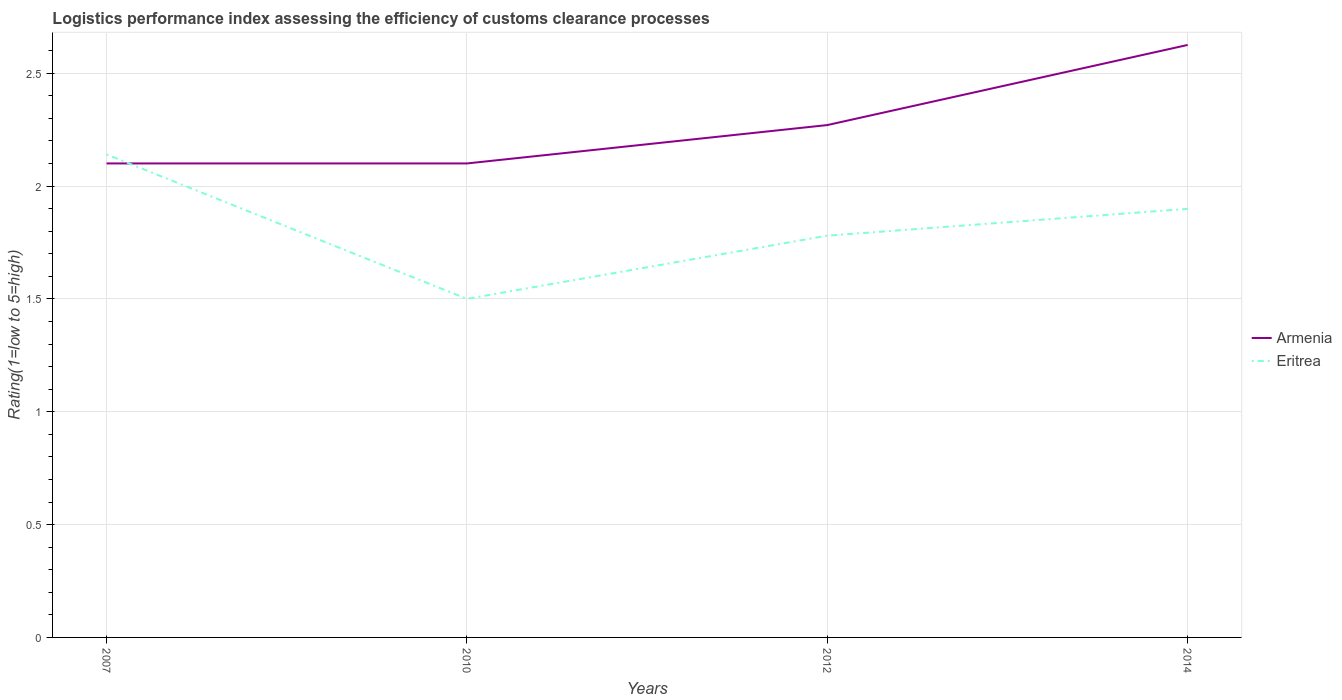Is the number of lines equal to the number of legend labels?
Ensure brevity in your answer.  Yes. Across all years, what is the maximum Logistic performance index in Eritrea?
Your answer should be compact. 1.5. In which year was the Logistic performance index in Armenia maximum?
Make the answer very short. 2007. What is the total Logistic performance index in Armenia in the graph?
Make the answer very short. -0.17. What is the difference between the highest and the second highest Logistic performance index in Eritrea?
Provide a succinct answer. 0.64. Is the Logistic performance index in Eritrea strictly greater than the Logistic performance index in Armenia over the years?
Offer a terse response. No. Are the values on the major ticks of Y-axis written in scientific E-notation?
Offer a terse response. No. Does the graph contain any zero values?
Make the answer very short. No. Does the graph contain grids?
Your answer should be very brief. Yes. How are the legend labels stacked?
Offer a very short reply. Vertical. What is the title of the graph?
Ensure brevity in your answer.  Logistics performance index assessing the efficiency of customs clearance processes. What is the label or title of the X-axis?
Your response must be concise. Years. What is the label or title of the Y-axis?
Provide a short and direct response. Rating(1=low to 5=high). What is the Rating(1=low to 5=high) in Eritrea in 2007?
Offer a terse response. 2.14. What is the Rating(1=low to 5=high) in Eritrea in 2010?
Offer a very short reply. 1.5. What is the Rating(1=low to 5=high) in Armenia in 2012?
Your response must be concise. 2.27. What is the Rating(1=low to 5=high) in Eritrea in 2012?
Make the answer very short. 1.78. What is the Rating(1=low to 5=high) in Armenia in 2014?
Keep it short and to the point. 2.62. What is the Rating(1=low to 5=high) in Eritrea in 2014?
Offer a very short reply. 1.9. Across all years, what is the maximum Rating(1=low to 5=high) in Armenia?
Keep it short and to the point. 2.62. Across all years, what is the maximum Rating(1=low to 5=high) in Eritrea?
Make the answer very short. 2.14. Across all years, what is the minimum Rating(1=low to 5=high) in Armenia?
Your response must be concise. 2.1. Across all years, what is the minimum Rating(1=low to 5=high) in Eritrea?
Your answer should be compact. 1.5. What is the total Rating(1=low to 5=high) of Armenia in the graph?
Your response must be concise. 9.1. What is the total Rating(1=low to 5=high) in Eritrea in the graph?
Your response must be concise. 7.32. What is the difference between the Rating(1=low to 5=high) of Eritrea in 2007 and that in 2010?
Make the answer very short. 0.64. What is the difference between the Rating(1=low to 5=high) of Armenia in 2007 and that in 2012?
Offer a very short reply. -0.17. What is the difference between the Rating(1=low to 5=high) in Eritrea in 2007 and that in 2012?
Your response must be concise. 0.36. What is the difference between the Rating(1=low to 5=high) in Armenia in 2007 and that in 2014?
Make the answer very short. -0.53. What is the difference between the Rating(1=low to 5=high) of Eritrea in 2007 and that in 2014?
Your answer should be compact. 0.24. What is the difference between the Rating(1=low to 5=high) of Armenia in 2010 and that in 2012?
Your answer should be compact. -0.17. What is the difference between the Rating(1=low to 5=high) in Eritrea in 2010 and that in 2012?
Your answer should be very brief. -0.28. What is the difference between the Rating(1=low to 5=high) of Armenia in 2010 and that in 2014?
Make the answer very short. -0.53. What is the difference between the Rating(1=low to 5=high) of Eritrea in 2010 and that in 2014?
Provide a short and direct response. -0.4. What is the difference between the Rating(1=low to 5=high) in Armenia in 2012 and that in 2014?
Ensure brevity in your answer.  -0.35. What is the difference between the Rating(1=low to 5=high) in Eritrea in 2012 and that in 2014?
Offer a very short reply. -0.12. What is the difference between the Rating(1=low to 5=high) in Armenia in 2007 and the Rating(1=low to 5=high) in Eritrea in 2010?
Provide a short and direct response. 0.6. What is the difference between the Rating(1=low to 5=high) of Armenia in 2007 and the Rating(1=low to 5=high) of Eritrea in 2012?
Give a very brief answer. 0.32. What is the difference between the Rating(1=low to 5=high) in Armenia in 2007 and the Rating(1=low to 5=high) in Eritrea in 2014?
Offer a terse response. 0.2. What is the difference between the Rating(1=low to 5=high) of Armenia in 2010 and the Rating(1=low to 5=high) of Eritrea in 2012?
Your response must be concise. 0.32. What is the difference between the Rating(1=low to 5=high) in Armenia in 2010 and the Rating(1=low to 5=high) in Eritrea in 2014?
Provide a short and direct response. 0.2. What is the difference between the Rating(1=low to 5=high) of Armenia in 2012 and the Rating(1=low to 5=high) of Eritrea in 2014?
Your answer should be very brief. 0.37. What is the average Rating(1=low to 5=high) of Armenia per year?
Make the answer very short. 2.27. What is the average Rating(1=low to 5=high) in Eritrea per year?
Keep it short and to the point. 1.83. In the year 2007, what is the difference between the Rating(1=low to 5=high) in Armenia and Rating(1=low to 5=high) in Eritrea?
Ensure brevity in your answer.  -0.04. In the year 2010, what is the difference between the Rating(1=low to 5=high) of Armenia and Rating(1=low to 5=high) of Eritrea?
Make the answer very short. 0.6. In the year 2012, what is the difference between the Rating(1=low to 5=high) in Armenia and Rating(1=low to 5=high) in Eritrea?
Provide a succinct answer. 0.49. In the year 2014, what is the difference between the Rating(1=low to 5=high) in Armenia and Rating(1=low to 5=high) in Eritrea?
Provide a succinct answer. 0.73. What is the ratio of the Rating(1=low to 5=high) in Eritrea in 2007 to that in 2010?
Your response must be concise. 1.43. What is the ratio of the Rating(1=low to 5=high) of Armenia in 2007 to that in 2012?
Keep it short and to the point. 0.93. What is the ratio of the Rating(1=low to 5=high) in Eritrea in 2007 to that in 2012?
Provide a short and direct response. 1.2. What is the ratio of the Rating(1=low to 5=high) of Eritrea in 2007 to that in 2014?
Your response must be concise. 1.13. What is the ratio of the Rating(1=low to 5=high) of Armenia in 2010 to that in 2012?
Keep it short and to the point. 0.93. What is the ratio of the Rating(1=low to 5=high) of Eritrea in 2010 to that in 2012?
Provide a short and direct response. 0.84. What is the ratio of the Rating(1=low to 5=high) in Armenia in 2010 to that in 2014?
Keep it short and to the point. 0.8. What is the ratio of the Rating(1=low to 5=high) in Eritrea in 2010 to that in 2014?
Your answer should be very brief. 0.79. What is the ratio of the Rating(1=low to 5=high) in Armenia in 2012 to that in 2014?
Give a very brief answer. 0.86. What is the ratio of the Rating(1=low to 5=high) in Eritrea in 2012 to that in 2014?
Your answer should be compact. 0.94. What is the difference between the highest and the second highest Rating(1=low to 5=high) in Armenia?
Offer a very short reply. 0.35. What is the difference between the highest and the second highest Rating(1=low to 5=high) in Eritrea?
Ensure brevity in your answer.  0.24. What is the difference between the highest and the lowest Rating(1=low to 5=high) in Armenia?
Make the answer very short. 0.53. What is the difference between the highest and the lowest Rating(1=low to 5=high) in Eritrea?
Make the answer very short. 0.64. 